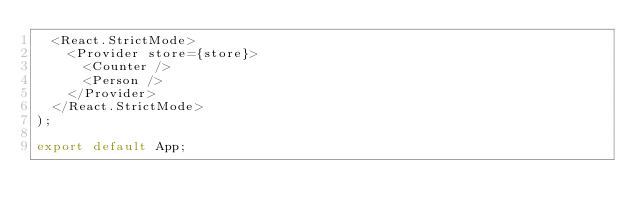Convert code to text. <code><loc_0><loc_0><loc_500><loc_500><_TypeScript_>  <React.StrictMode>
    <Provider store={store}>
      <Counter />
      <Person />
    </Provider>
  </React.StrictMode>
);

export default App;
</code> 